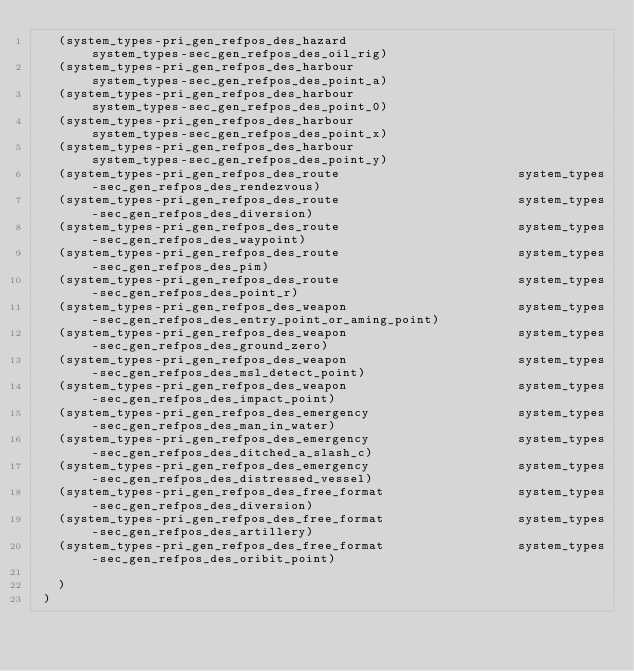Convert code to text. <code><loc_0><loc_0><loc_500><loc_500><_Scheme_>   (system_types-pri_gen_refpos_des_hazard                        system_types-sec_gen_refpos_des_oil_rig)
   (system_types-pri_gen_refpos_des_harbour                       system_types-sec_gen_refpos_des_point_a)
   (system_types-pri_gen_refpos_des_harbour                       system_types-sec_gen_refpos_des_point_0)
   (system_types-pri_gen_refpos_des_harbour                       system_types-sec_gen_refpos_des_point_x)
   (system_types-pri_gen_refpos_des_harbour                       system_types-sec_gen_refpos_des_point_y)
   (system_types-pri_gen_refpos_des_route                        system_types-sec_gen_refpos_des_rendezvous)
   (system_types-pri_gen_refpos_des_route                        system_types-sec_gen_refpos_des_diversion)
   (system_types-pri_gen_refpos_des_route                        system_types-sec_gen_refpos_des_waypoint)
   (system_types-pri_gen_refpos_des_route                        system_types-sec_gen_refpos_des_pim)
   (system_types-pri_gen_refpos_des_route                        system_types-sec_gen_refpos_des_point_r)
   (system_types-pri_gen_refpos_des_weapon                       system_types-sec_gen_refpos_des_entry_point_or_aming_point)
   (system_types-pri_gen_refpos_des_weapon                       system_types-sec_gen_refpos_des_ground_zero)
   (system_types-pri_gen_refpos_des_weapon                       system_types-sec_gen_refpos_des_msl_detect_point)
   (system_types-pri_gen_refpos_des_weapon                       system_types-sec_gen_refpos_des_impact_point)
   (system_types-pri_gen_refpos_des_emergency                    system_types-sec_gen_refpos_des_man_in_water)
   (system_types-pri_gen_refpos_des_emergency                    system_types-sec_gen_refpos_des_ditched_a_slash_c)
   (system_types-pri_gen_refpos_des_emergency                    system_types-sec_gen_refpos_des_distressed_vessel)
   (system_types-pri_gen_refpos_des_free_format                  system_types-sec_gen_refpos_des_diversion)
   (system_types-pri_gen_refpos_des_free_format                  system_types-sec_gen_refpos_des_artillery)
   (system_types-pri_gen_refpos_des_free_format                  system_types-sec_gen_refpos_des_oribit_point)

   )
 )






</code> 